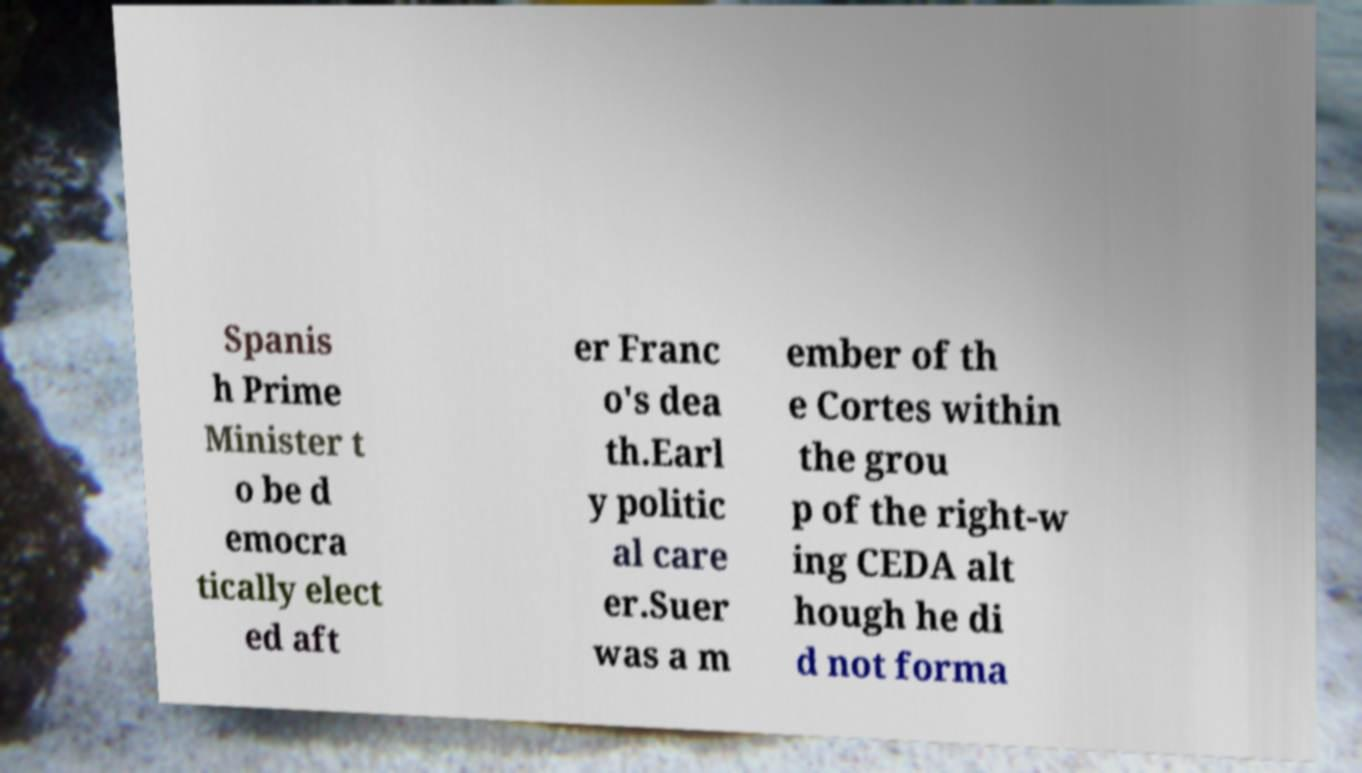There's text embedded in this image that I need extracted. Can you transcribe it verbatim? Spanis h Prime Minister t o be d emocra tically elect ed aft er Franc o's dea th.Earl y politic al care er.Suer was a m ember of th e Cortes within the grou p of the right-w ing CEDA alt hough he di d not forma 